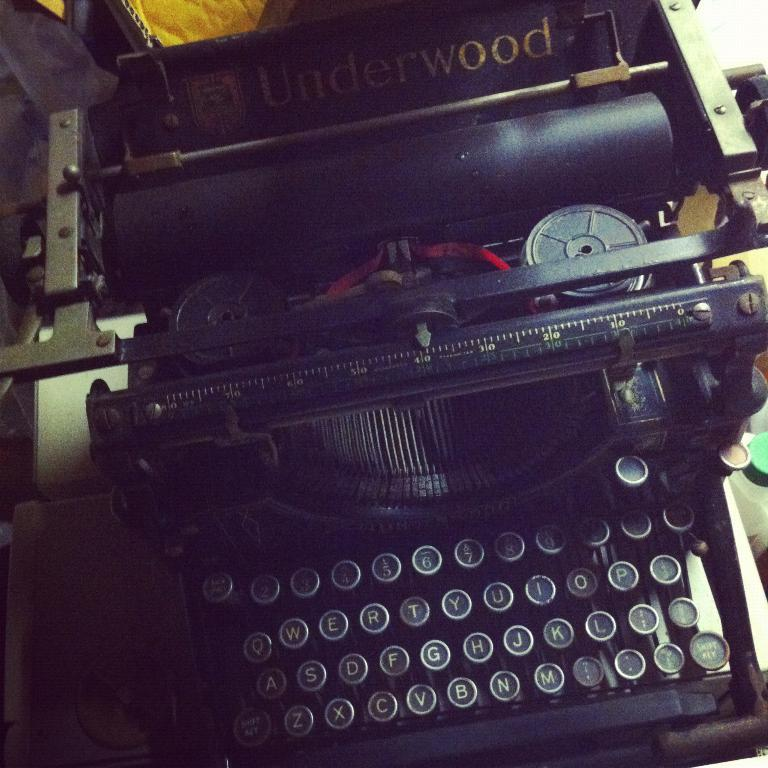<image>
Relay a brief, clear account of the picture shown. old black manual typewriter that has Underwood labeled toward the back of it 